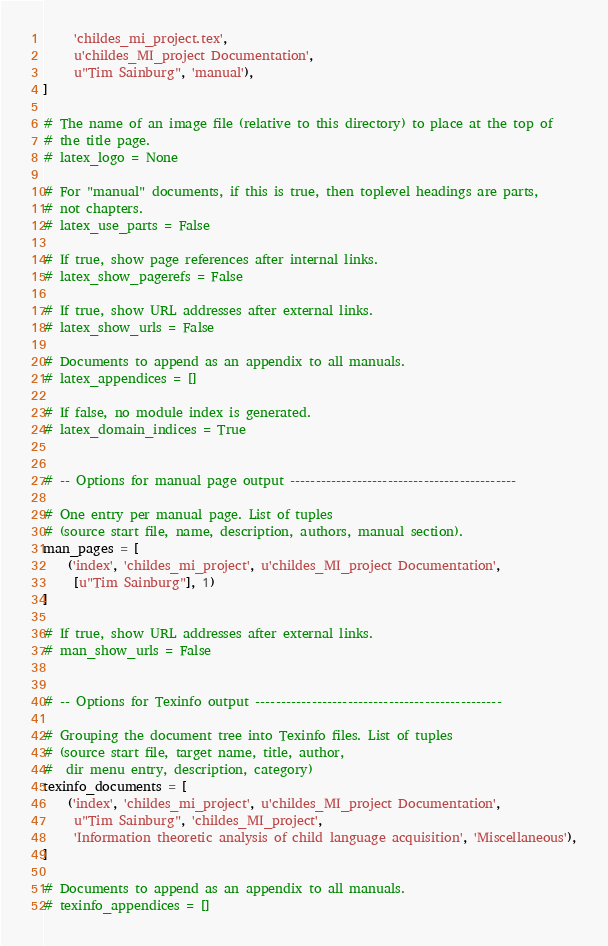Convert code to text. <code><loc_0><loc_0><loc_500><loc_500><_Python_>     'childes_mi_project.tex',
     u'childes_MI_project Documentation',
     u"Tim Sainburg", 'manual'),
]

# The name of an image file (relative to this directory) to place at the top of
# the title page.
# latex_logo = None

# For "manual" documents, if this is true, then toplevel headings are parts,
# not chapters.
# latex_use_parts = False

# If true, show page references after internal links.
# latex_show_pagerefs = False

# If true, show URL addresses after external links.
# latex_show_urls = False

# Documents to append as an appendix to all manuals.
# latex_appendices = []

# If false, no module index is generated.
# latex_domain_indices = True


# -- Options for manual page output --------------------------------------------

# One entry per manual page. List of tuples
# (source start file, name, description, authors, manual section).
man_pages = [
    ('index', 'childes_mi_project', u'childes_MI_project Documentation',
     [u"Tim Sainburg"], 1)
]

# If true, show URL addresses after external links.
# man_show_urls = False


# -- Options for Texinfo output ------------------------------------------------

# Grouping the document tree into Texinfo files. List of tuples
# (source start file, target name, title, author,
#  dir menu entry, description, category)
texinfo_documents = [
    ('index', 'childes_mi_project', u'childes_MI_project Documentation',
     u"Tim Sainburg", 'childes_MI_project',
     'Information theoretic analysis of child language acquisition', 'Miscellaneous'),
]

# Documents to append as an appendix to all manuals.
# texinfo_appendices = []
</code> 